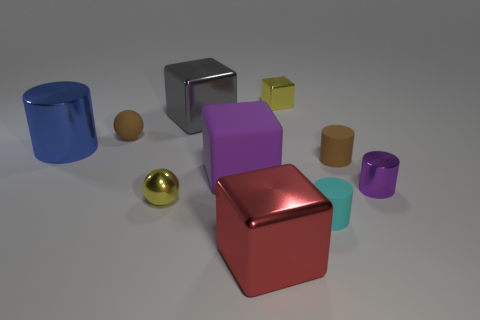What is the red block made of?
Your answer should be compact. Metal. How many tiny objects are there?
Ensure brevity in your answer.  6. Does the tiny metal object that is behind the blue object have the same color as the tiny cylinder that is in front of the shiny sphere?
Give a very brief answer. No. There is a sphere that is the same color as the small metal block; what is its size?
Make the answer very short. Small. How many other things are there of the same size as the purple shiny cylinder?
Ensure brevity in your answer.  5. What is the color of the shiny thing that is to the right of the tiny metallic block?
Keep it short and to the point. Purple. Is the purple object that is behind the purple cylinder made of the same material as the big red block?
Your answer should be very brief. No. How many metallic objects are behind the tiny shiny ball and on the left side of the large red shiny object?
Give a very brief answer. 2. There is a sphere behind the purple object to the left of the big shiny thing in front of the cyan cylinder; what is its color?
Provide a short and direct response. Brown. There is a small yellow thing that is behind the brown sphere; are there any purple objects in front of it?
Provide a short and direct response. Yes. 